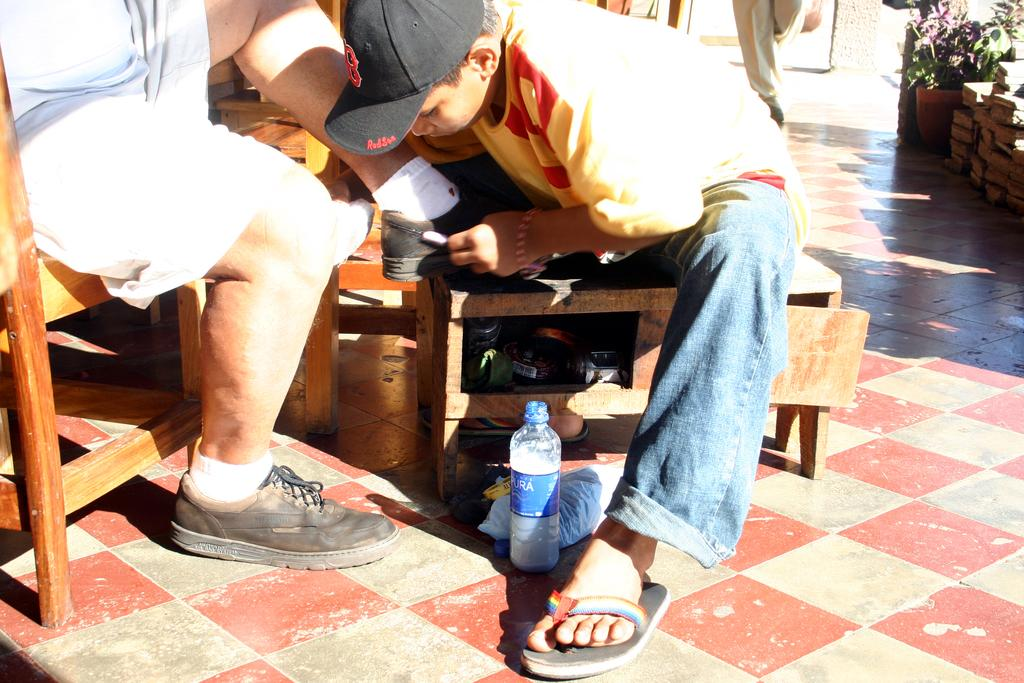How many people are in the image? There are two persons in the image. What are the persons doing in the image? The persons are sitting on chairs. What is the surface visible in the image? The image shows a floor. What object can be seen in the image besides the persons and chairs? There is a bottle and a plant in the image. How many hens are visible in the image? There are no hens present in the image. What type of cakes are being served on the table in the image? There is no table or cakes visible in the image. 